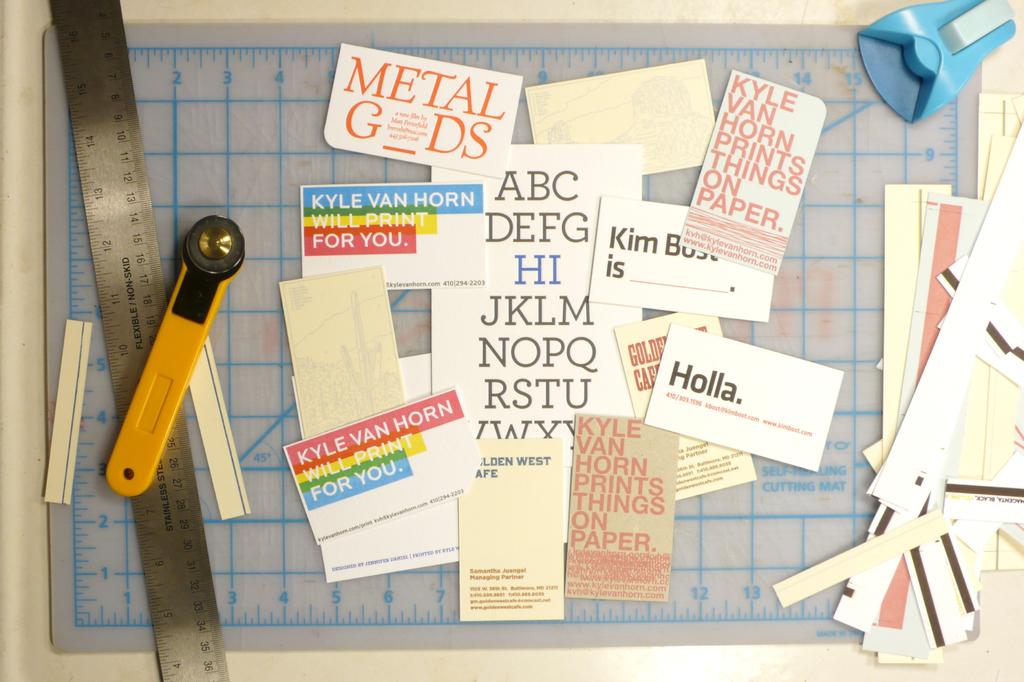Who will print it for you?
Provide a succinct answer. Kyle van horn. 